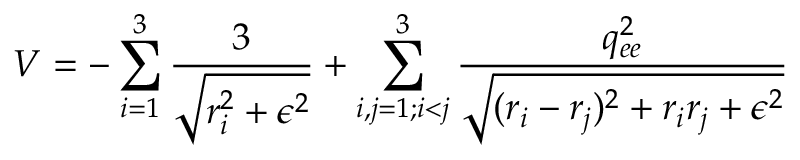Convert formula to latex. <formula><loc_0><loc_0><loc_500><loc_500>V = - \sum _ { i = 1 } ^ { 3 } \frac { 3 } { \sqrt { r _ { i } ^ { 2 } + \epsilon ^ { 2 } } } + \sum _ { i , j = 1 ; i < j } ^ { 3 } \frac { q _ { e e } ^ { 2 } } { \sqrt { ( r _ { i } - r _ { j } ) ^ { 2 } + r _ { i } r _ { j } + \epsilon ^ { 2 } } }</formula> 